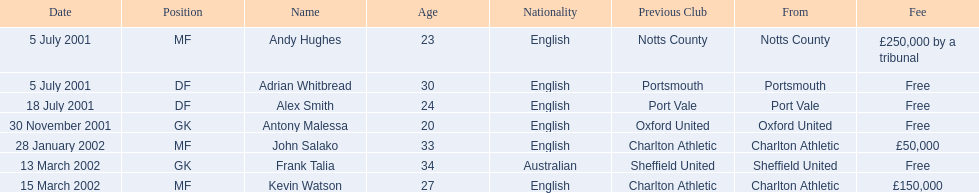List all the players names Andy Hughes, Adrian Whitbread, Alex Smith, Antony Malessa, John Salako, Frank Talia, Kevin Watson. Of these who is kevin watson Kevin Watson. To what transfer fee entry does kevin correspond to? £150,000. 